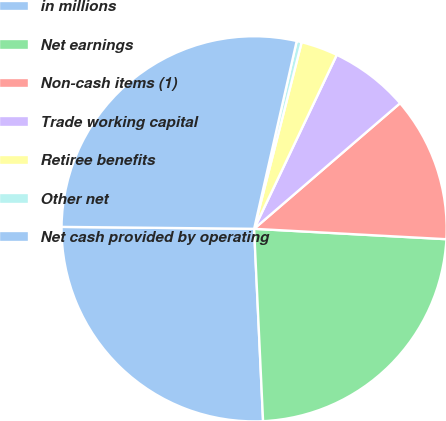<chart> <loc_0><loc_0><loc_500><loc_500><pie_chart><fcel>in millions<fcel>Net earnings<fcel>Non-cash items (1)<fcel>Trade working capital<fcel>Retiree benefits<fcel>Other net<fcel>Net cash provided by operating<nl><fcel>25.9%<fcel>23.4%<fcel>12.17%<fcel>6.63%<fcel>3.09%<fcel>0.42%<fcel>28.39%<nl></chart> 